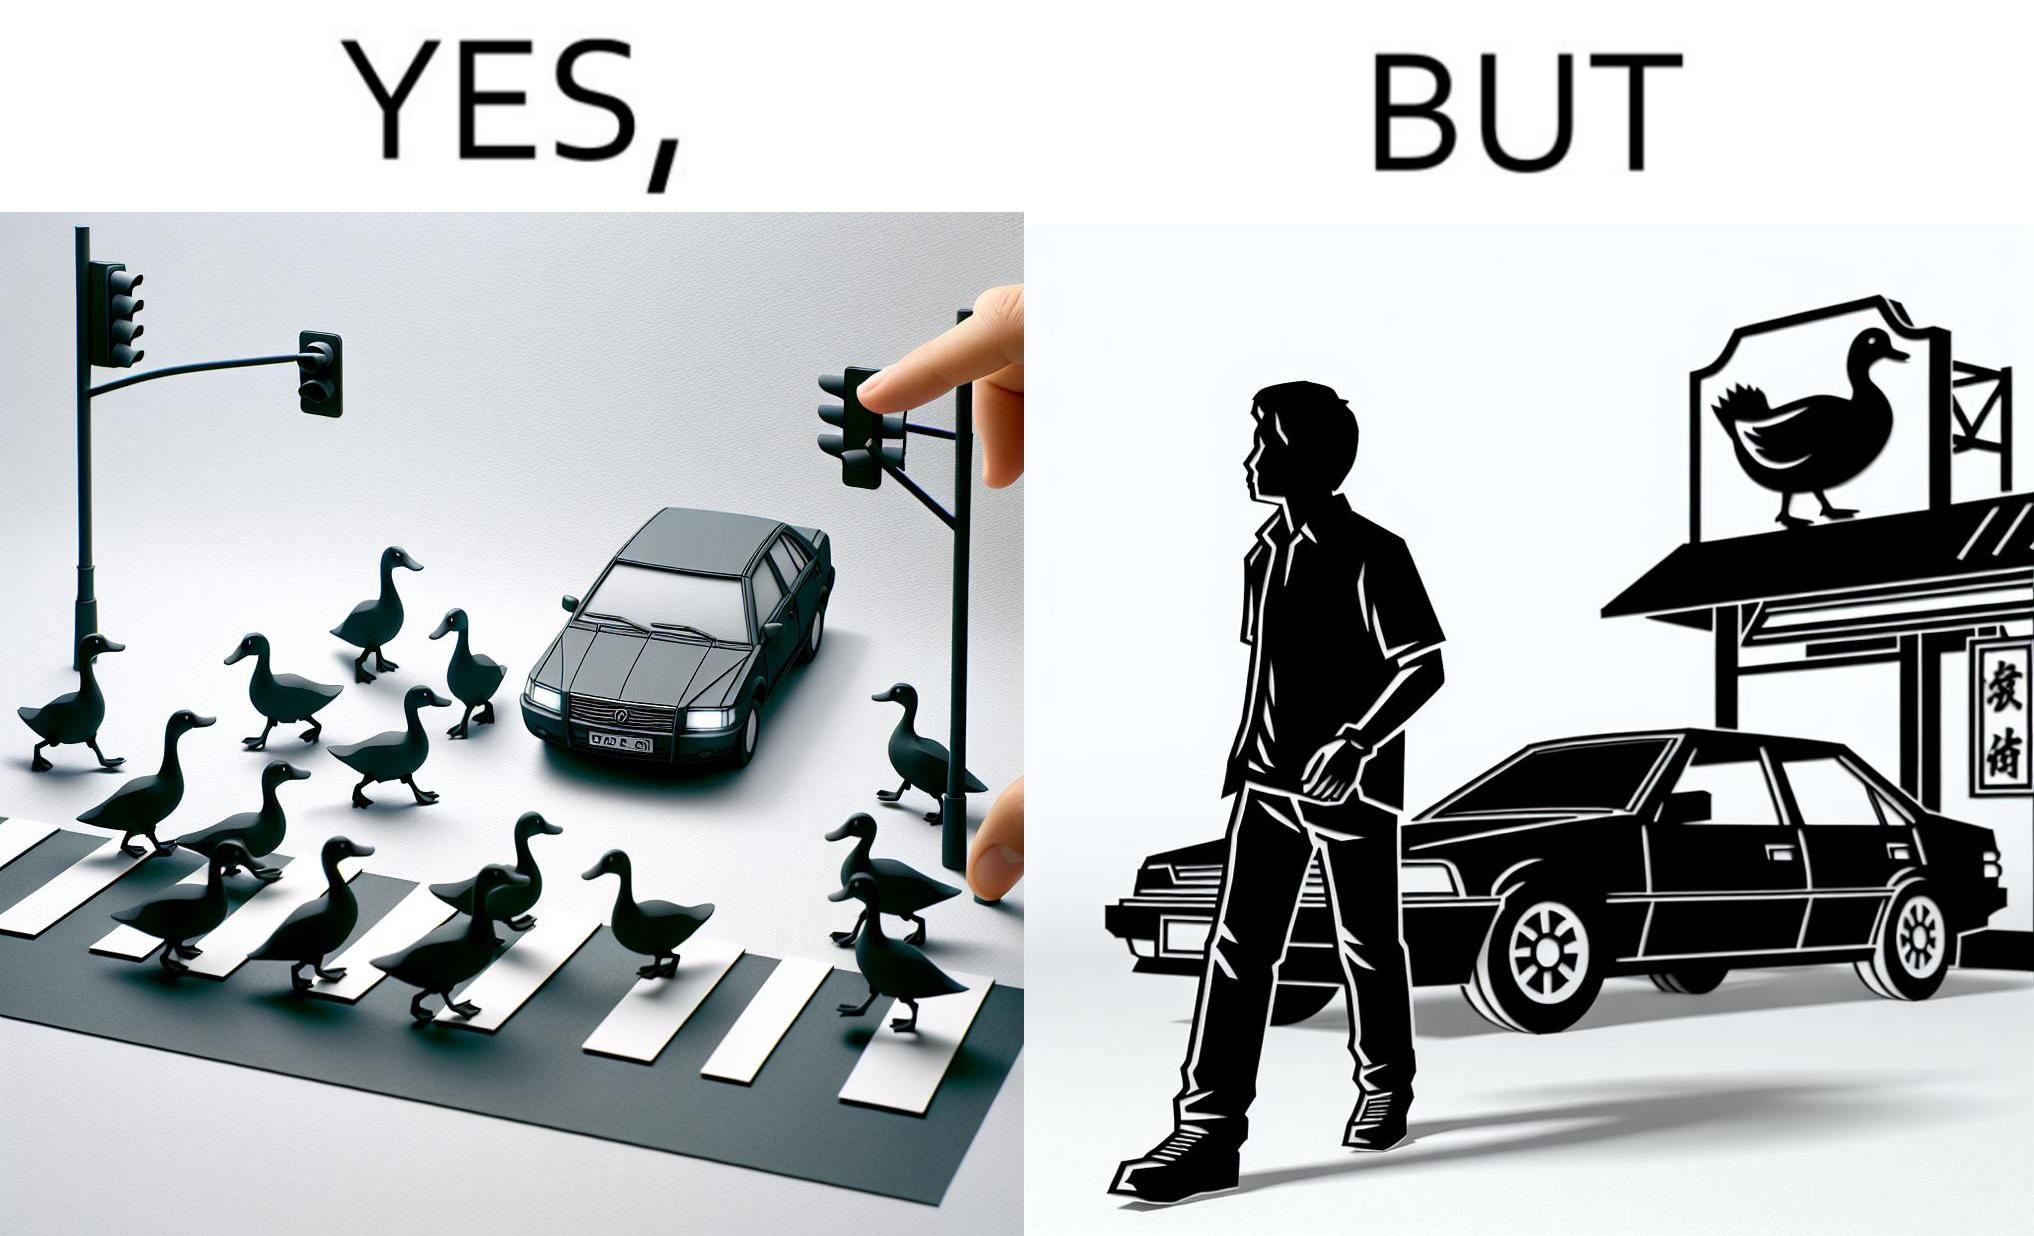Why is this image considered satirical? The images are ironic since they show how a man supposedly cares for ducks since he stops his vehicle to give way to queue of ducks allowing them to safely cross a road but on the other hand he goes to a peking duck shop to buy and eat similar ducks after having them killed 